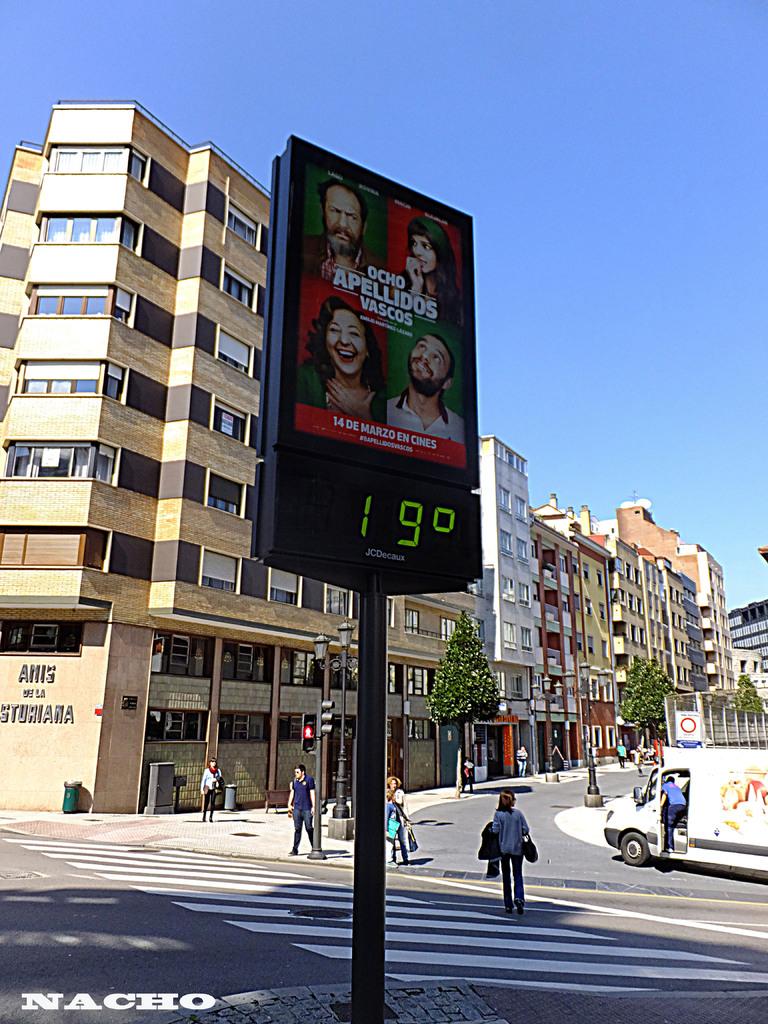What is the temperature?
Your response must be concise. 19. 